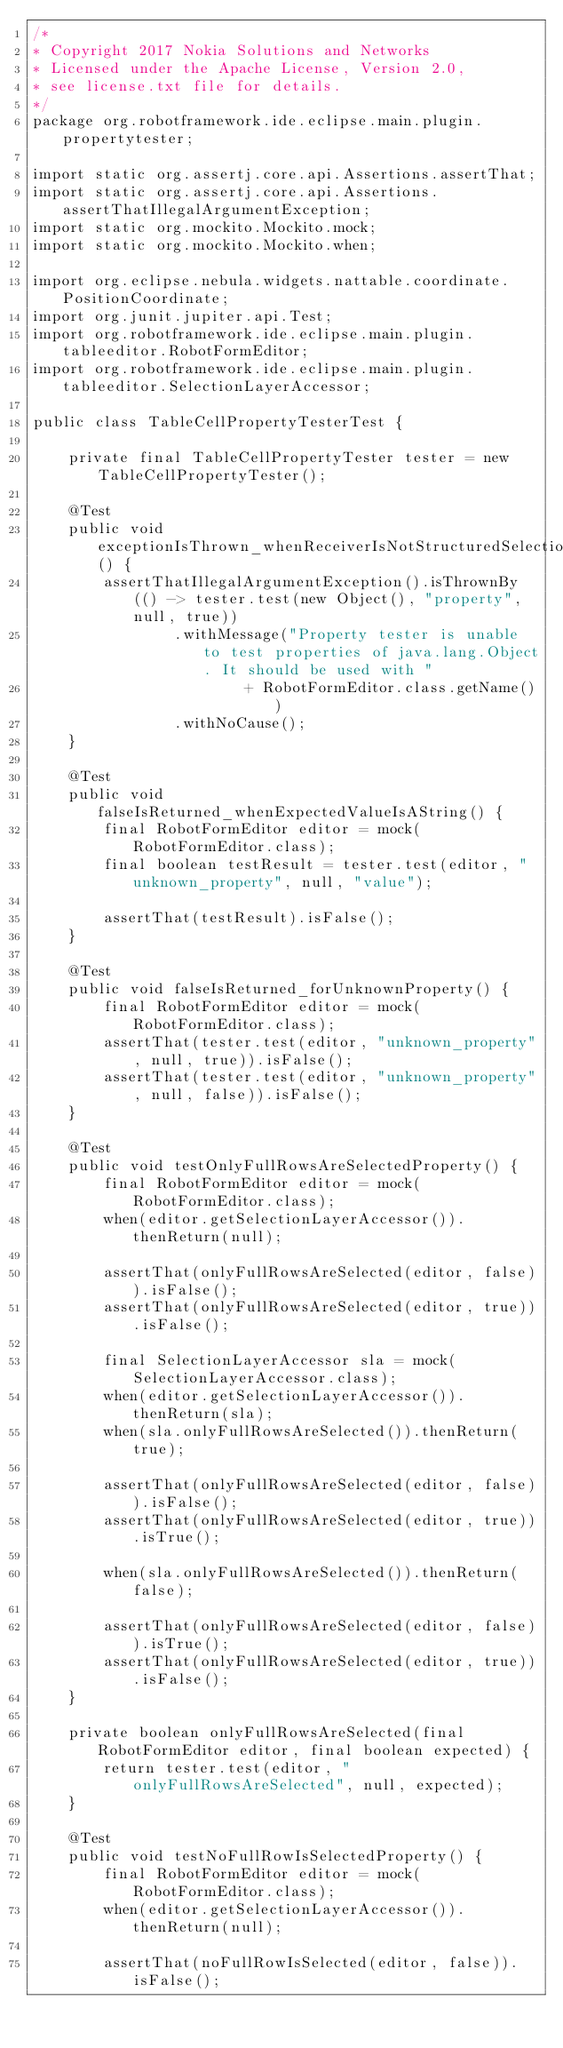<code> <loc_0><loc_0><loc_500><loc_500><_Java_>/*
* Copyright 2017 Nokia Solutions and Networks
* Licensed under the Apache License, Version 2.0,
* see license.txt file for details.
*/
package org.robotframework.ide.eclipse.main.plugin.propertytester;

import static org.assertj.core.api.Assertions.assertThat;
import static org.assertj.core.api.Assertions.assertThatIllegalArgumentException;
import static org.mockito.Mockito.mock;
import static org.mockito.Mockito.when;

import org.eclipse.nebula.widgets.nattable.coordinate.PositionCoordinate;
import org.junit.jupiter.api.Test;
import org.robotframework.ide.eclipse.main.plugin.tableeditor.RobotFormEditor;
import org.robotframework.ide.eclipse.main.plugin.tableeditor.SelectionLayerAccessor;

public class TableCellPropertyTesterTest {

    private final TableCellPropertyTester tester = new TableCellPropertyTester();

    @Test
    public void exceptionIsThrown_whenReceiverIsNotStructuredSelection() {
        assertThatIllegalArgumentException().isThrownBy(() -> tester.test(new Object(), "property", null, true))
                .withMessage("Property tester is unable to test properties of java.lang.Object. It should be used with "
                        + RobotFormEditor.class.getName())
                .withNoCause();
    }

    @Test
    public void falseIsReturned_whenExpectedValueIsAString() {
        final RobotFormEditor editor = mock(RobotFormEditor.class);
        final boolean testResult = tester.test(editor, "unknown_property", null, "value");

        assertThat(testResult).isFalse();
    }

    @Test
    public void falseIsReturned_forUnknownProperty() {
        final RobotFormEditor editor = mock(RobotFormEditor.class);
        assertThat(tester.test(editor, "unknown_property", null, true)).isFalse();
        assertThat(tester.test(editor, "unknown_property", null, false)).isFalse();
    }

    @Test
    public void testOnlyFullRowsAreSelectedProperty() {
        final RobotFormEditor editor = mock(RobotFormEditor.class);
        when(editor.getSelectionLayerAccessor()).thenReturn(null);

        assertThat(onlyFullRowsAreSelected(editor, false)).isFalse();
        assertThat(onlyFullRowsAreSelected(editor, true)).isFalse();

        final SelectionLayerAccessor sla = mock(SelectionLayerAccessor.class);
        when(editor.getSelectionLayerAccessor()).thenReturn(sla);
        when(sla.onlyFullRowsAreSelected()).thenReturn(true);

        assertThat(onlyFullRowsAreSelected(editor, false)).isFalse();
        assertThat(onlyFullRowsAreSelected(editor, true)).isTrue();

        when(sla.onlyFullRowsAreSelected()).thenReturn(false);

        assertThat(onlyFullRowsAreSelected(editor, false)).isTrue();
        assertThat(onlyFullRowsAreSelected(editor, true)).isFalse();
    }

    private boolean onlyFullRowsAreSelected(final RobotFormEditor editor, final boolean expected) {
        return tester.test(editor, "onlyFullRowsAreSelected", null, expected);
    }

    @Test
    public void testNoFullRowIsSelectedProperty() {
        final RobotFormEditor editor = mock(RobotFormEditor.class);
        when(editor.getSelectionLayerAccessor()).thenReturn(null);

        assertThat(noFullRowIsSelected(editor, false)).isFalse();</code> 